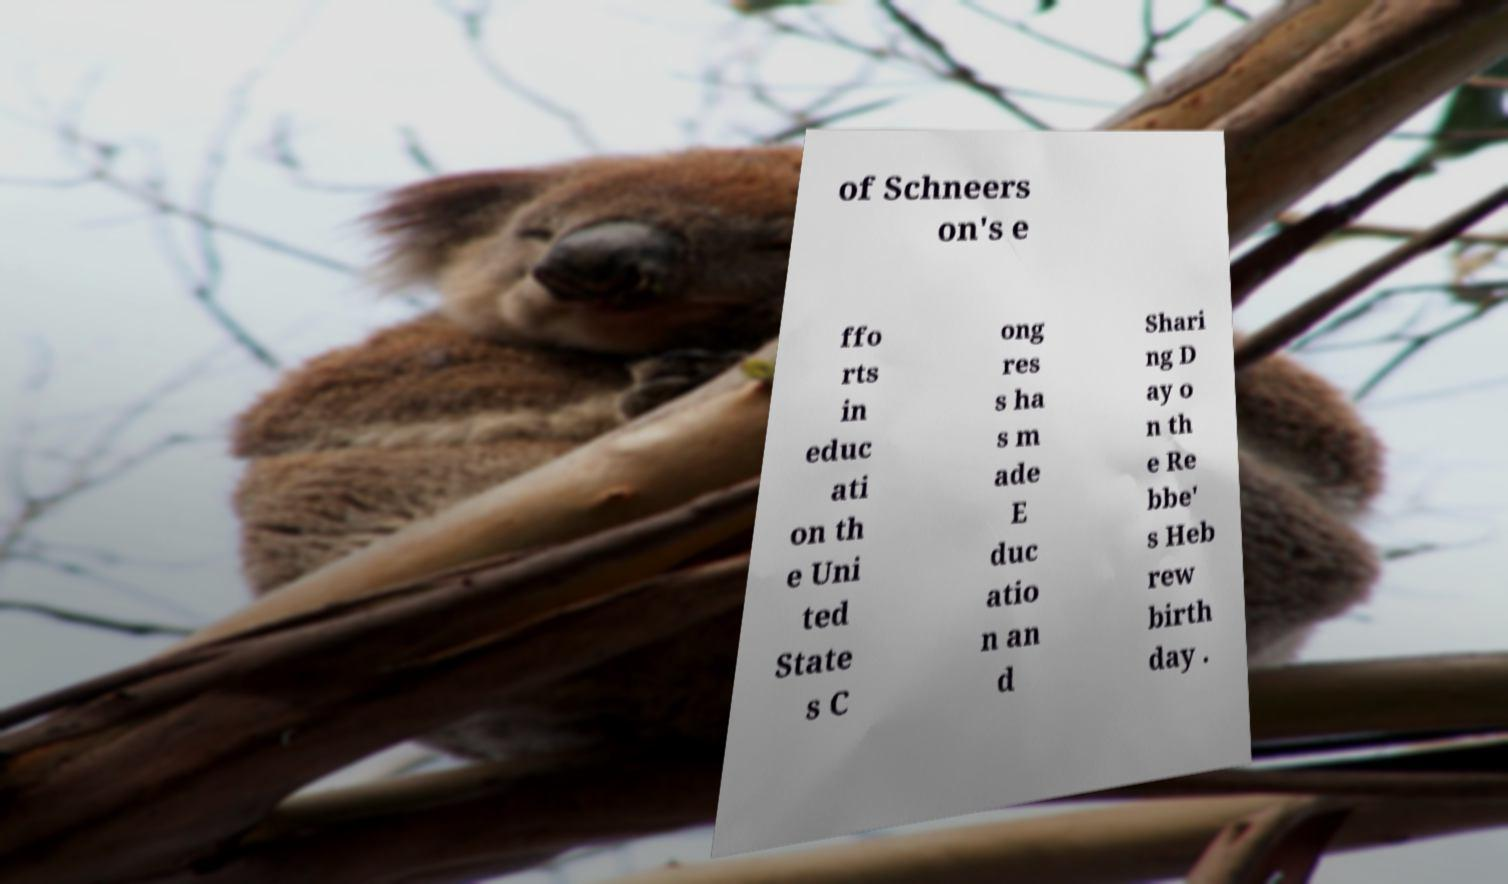Can you accurately transcribe the text from the provided image for me? of Schneers on's e ffo rts in educ ati on th e Uni ted State s C ong res s ha s m ade E duc atio n an d Shari ng D ay o n th e Re bbe' s Heb rew birth day . 